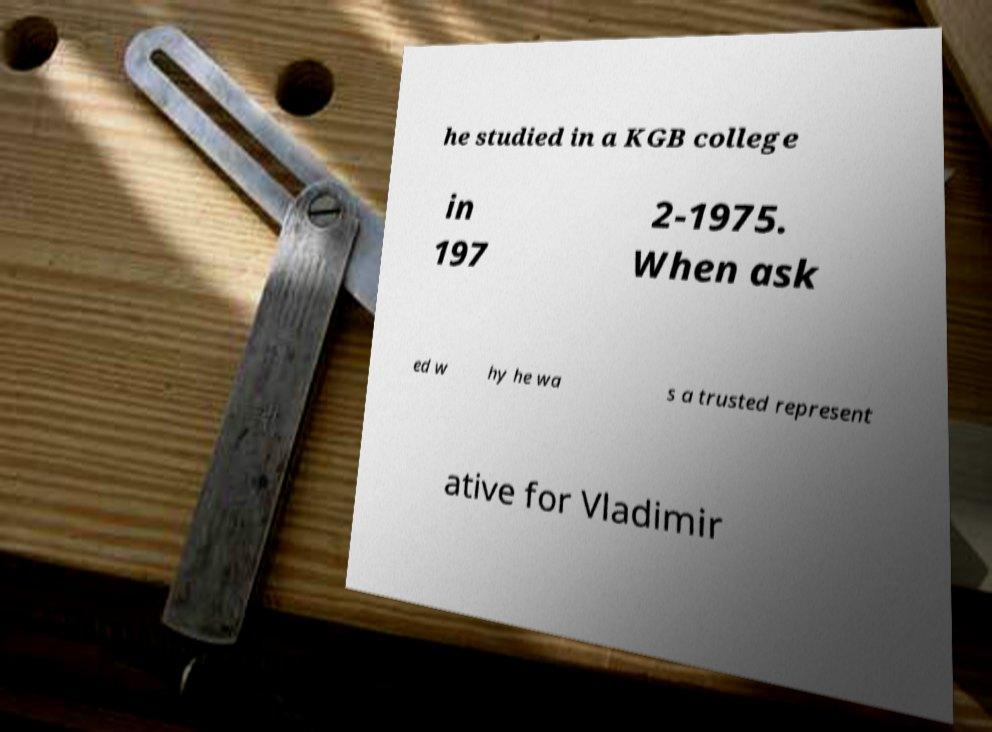Could you assist in decoding the text presented in this image and type it out clearly? he studied in a KGB college in 197 2-1975. When ask ed w hy he wa s a trusted represent ative for Vladimir 